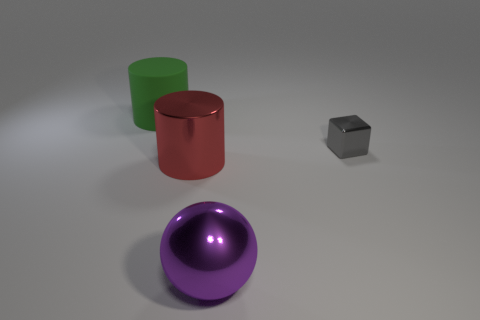Add 1 big purple things. How many objects exist? 5 Subtract all red cylinders. How many cylinders are left? 1 Subtract 1 spheres. How many spheres are left? 0 Subtract all balls. How many objects are left? 3 Add 1 big rubber objects. How many big rubber objects exist? 2 Subtract 0 green cubes. How many objects are left? 4 Subtract all brown blocks. Subtract all red cylinders. How many blocks are left? 1 Subtract all gray balls. How many brown cylinders are left? 0 Subtract all red things. Subtract all large objects. How many objects are left? 0 Add 4 matte cylinders. How many matte cylinders are left? 5 